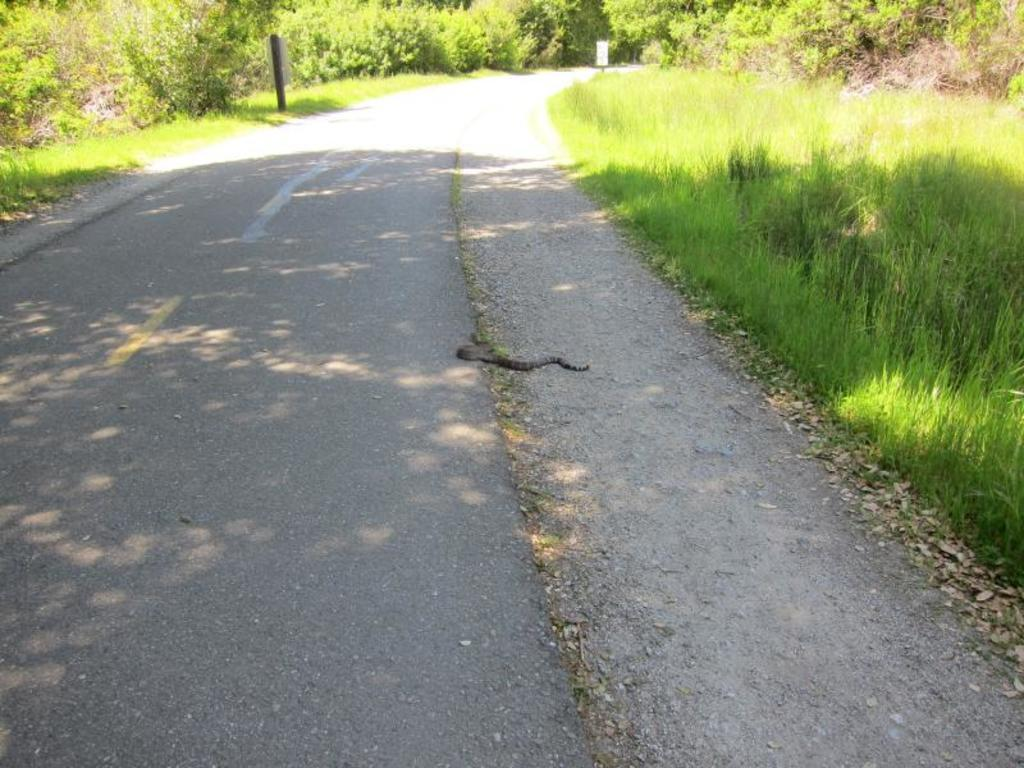What is the main feature of the image? There is a road in the image. What can be seen on either side of the road? Grass and trees are visible on either side of the road. What objects are located on the left side of the image? There is a board and a pole on the left side of the image. Can you describe the presence of a snake in the image? A snake is present on the ground in the image. How many people are in the group that is touching the level in the image? There is no group or level present in the image; it features a road, grass, trees, a board, a pole, and a snake. 